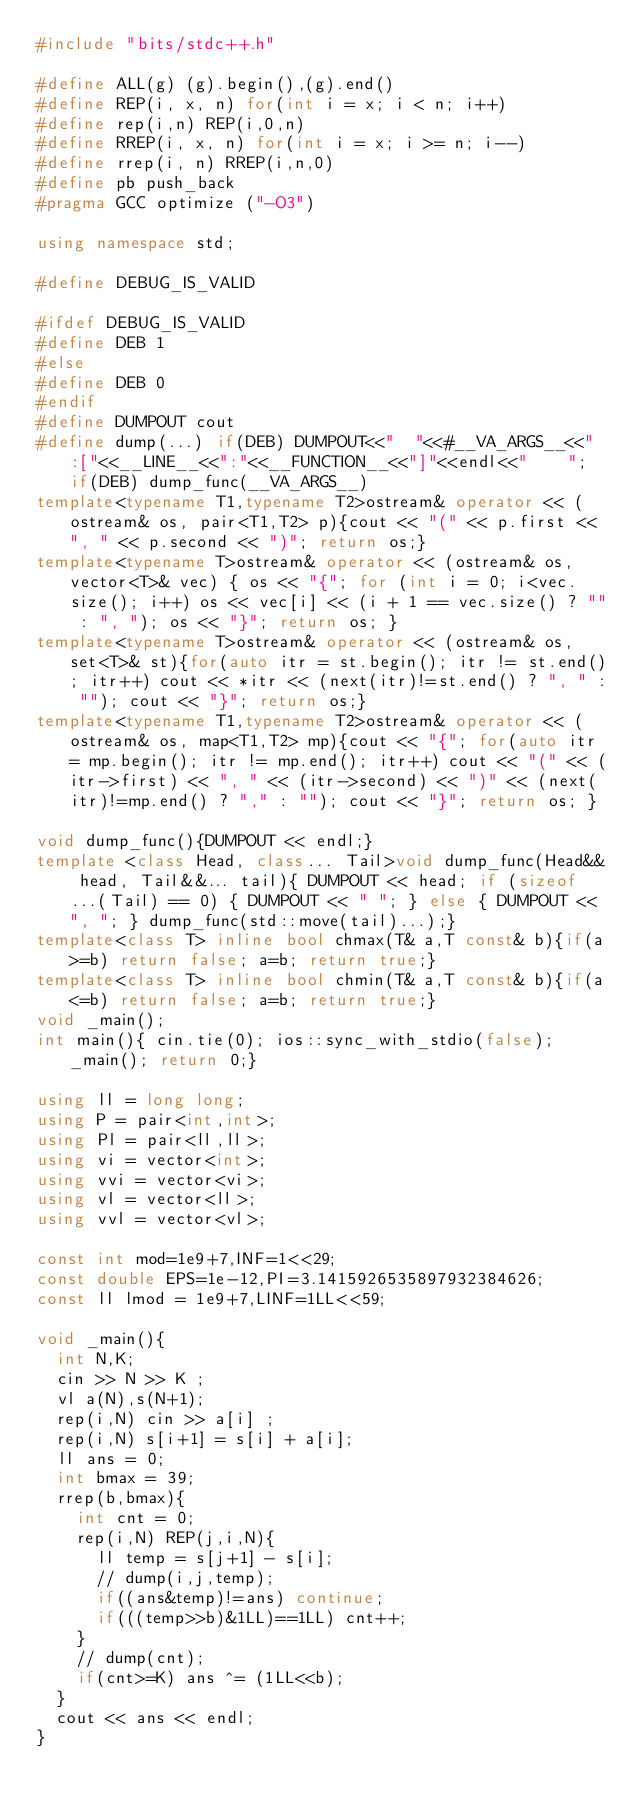Convert code to text. <code><loc_0><loc_0><loc_500><loc_500><_C++_>#include "bits/stdc++.h"

#define ALL(g) (g).begin(),(g).end()
#define REP(i, x, n) for(int i = x; i < n; i++)
#define rep(i,n) REP(i,0,n)
#define RREP(i, x, n) for(int i = x; i >= n; i--)
#define rrep(i, n) RREP(i,n,0)
#define pb push_back
#pragma GCC optimize ("-O3")

using namespace std;

#define DEBUG_IS_VALID

#ifdef DEBUG_IS_VALID
#define DEB 1 
#else
#define DEB 0
#endif
#define DUMPOUT cout
#define dump(...) if(DEB) DUMPOUT<<"  "<<#__VA_ARGS__<<" :["<<__LINE__<<":"<<__FUNCTION__<<"]"<<endl<<"    "; if(DEB) dump_func(__VA_ARGS__)
template<typename T1,typename T2>ostream& operator << (ostream& os, pair<T1,T2> p){cout << "(" << p.first << ", " << p.second << ")"; return os;}
template<typename T>ostream& operator << (ostream& os, vector<T>& vec) { os << "{"; for (int i = 0; i<vec.size(); i++) os << vec[i] << (i + 1 == vec.size() ? "" : ", "); os << "}"; return os; }
template<typename T>ostream& operator << (ostream& os, set<T>& st){for(auto itr = st.begin(); itr != st.end(); itr++) cout << *itr << (next(itr)!=st.end() ? ", " : ""); cout << "}"; return os;}
template<typename T1,typename T2>ostream& operator << (ostream& os, map<T1,T2> mp){cout << "{"; for(auto itr = mp.begin(); itr != mp.end(); itr++) cout << "(" << (itr->first) << ", " << (itr->second) << ")" << (next(itr)!=mp.end() ? "," : ""); cout << "}"; return os; }

void dump_func(){DUMPOUT << endl;}
template <class Head, class... Tail>void dump_func(Head&& head, Tail&&... tail){ DUMPOUT << head; if (sizeof...(Tail) == 0) { DUMPOUT << " "; } else { DUMPOUT << ", "; } dump_func(std::move(tail)...);}
template<class T> inline bool chmax(T& a,T const& b){if(a>=b) return false; a=b; return true;}
template<class T> inline bool chmin(T& a,T const& b){if(a<=b) return false; a=b; return true;}
void _main();
int main(){ cin.tie(0); ios::sync_with_stdio(false); _main(); return 0;}

using ll = long long;
using P = pair<int,int>;
using Pl = pair<ll,ll>;
using vi = vector<int>;
using vvi = vector<vi>;
using vl = vector<ll>;
using vvl = vector<vl>;

const int mod=1e9+7,INF=1<<29;
const double EPS=1e-12,PI=3.1415926535897932384626;
const ll lmod = 1e9+7,LINF=1LL<<59; 

void _main(){
  int N,K;
  cin >> N >> K ;
  vl a(N),s(N+1);
  rep(i,N) cin >> a[i] ;
  rep(i,N) s[i+1] = s[i] + a[i];
  ll ans = 0;
  int bmax = 39;
  rrep(b,bmax){
    int cnt = 0;
    rep(i,N) REP(j,i,N){
      ll temp = s[j+1] - s[i];
      // dump(i,j,temp);
      if((ans&temp)!=ans) continue;
      if(((temp>>b)&1LL)==1LL) cnt++;
    }
    // dump(cnt);
    if(cnt>=K) ans ^= (1LL<<b);
  }
  cout << ans << endl;
}</code> 